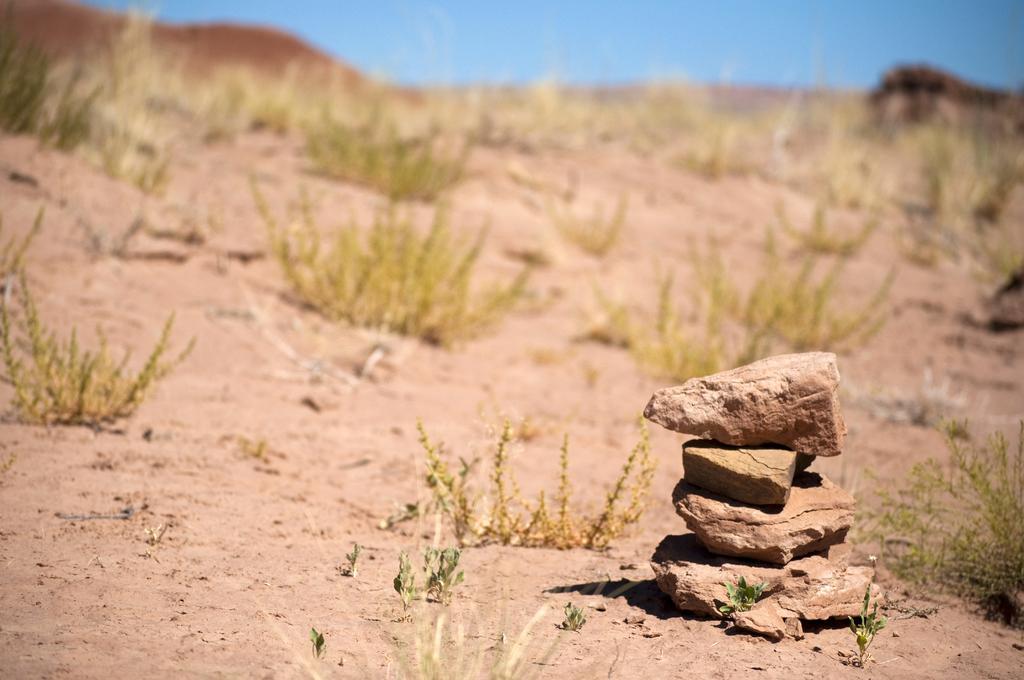Describe this image in one or two sentences. In this image we can see some stones placed one on the other on the ground. We can also see some plants and the sky. 